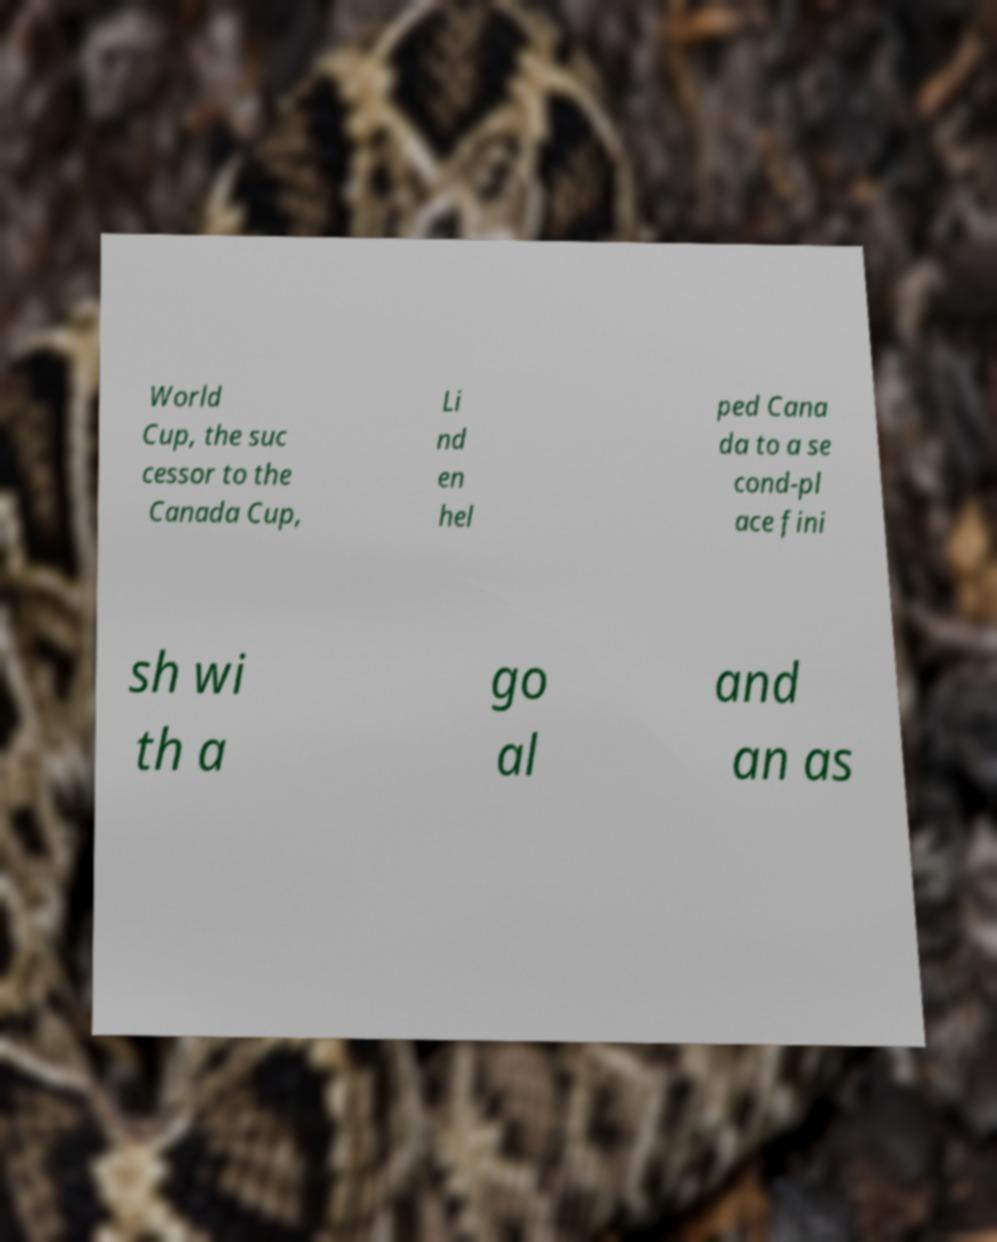There's text embedded in this image that I need extracted. Can you transcribe it verbatim? World Cup, the suc cessor to the Canada Cup, Li nd en hel ped Cana da to a se cond-pl ace fini sh wi th a go al and an as 